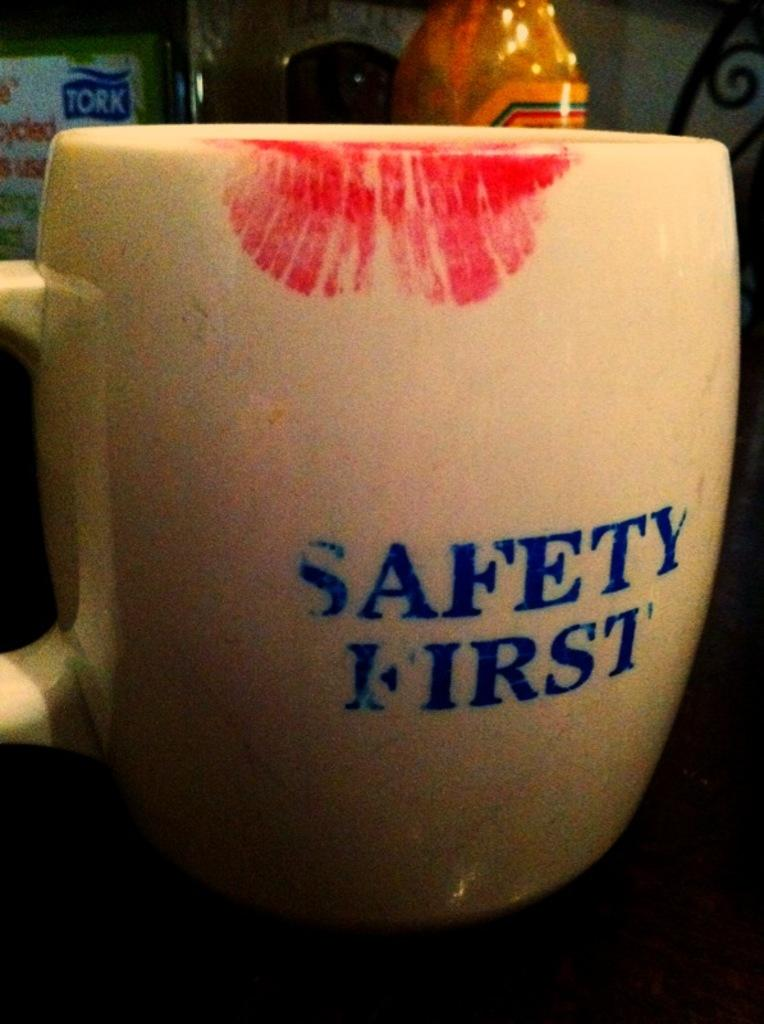Provide a one-sentence caption for the provided image. A mug with a lip stain that says Safety First. 